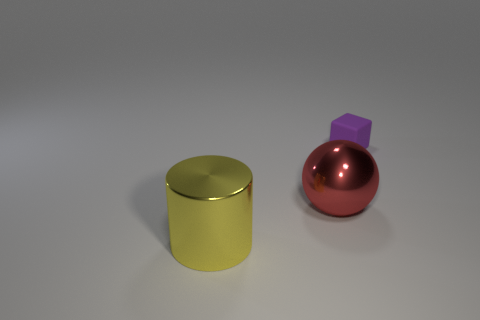Add 2 metallic cubes. How many objects exist? 5 Subtract all balls. How many objects are left? 2 Subtract 1 blocks. How many blocks are left? 0 Subtract 0 cyan cubes. How many objects are left? 3 Subtract all cyan metallic cylinders. Subtract all large yellow things. How many objects are left? 2 Add 2 small rubber things. How many small rubber things are left? 3 Add 1 yellow metallic spheres. How many yellow metallic spheres exist? 1 